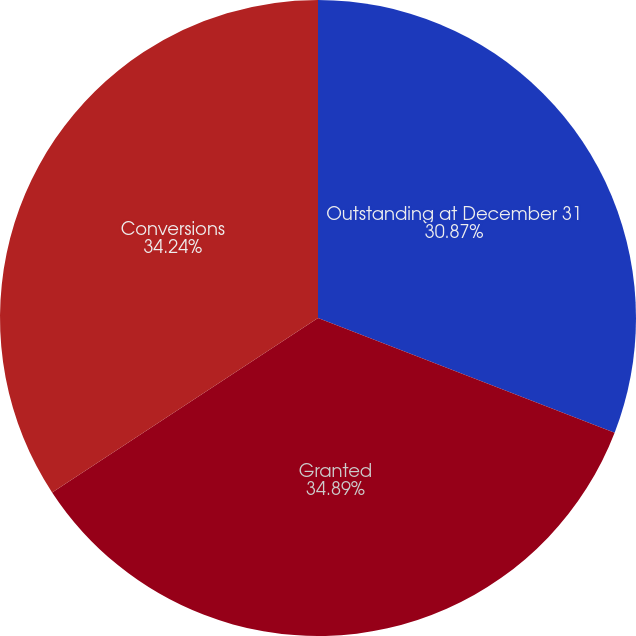Convert chart. <chart><loc_0><loc_0><loc_500><loc_500><pie_chart><fcel>Outstanding at December 31<fcel>Granted<fcel>Conversions<nl><fcel>30.87%<fcel>34.89%<fcel>34.24%<nl></chart> 